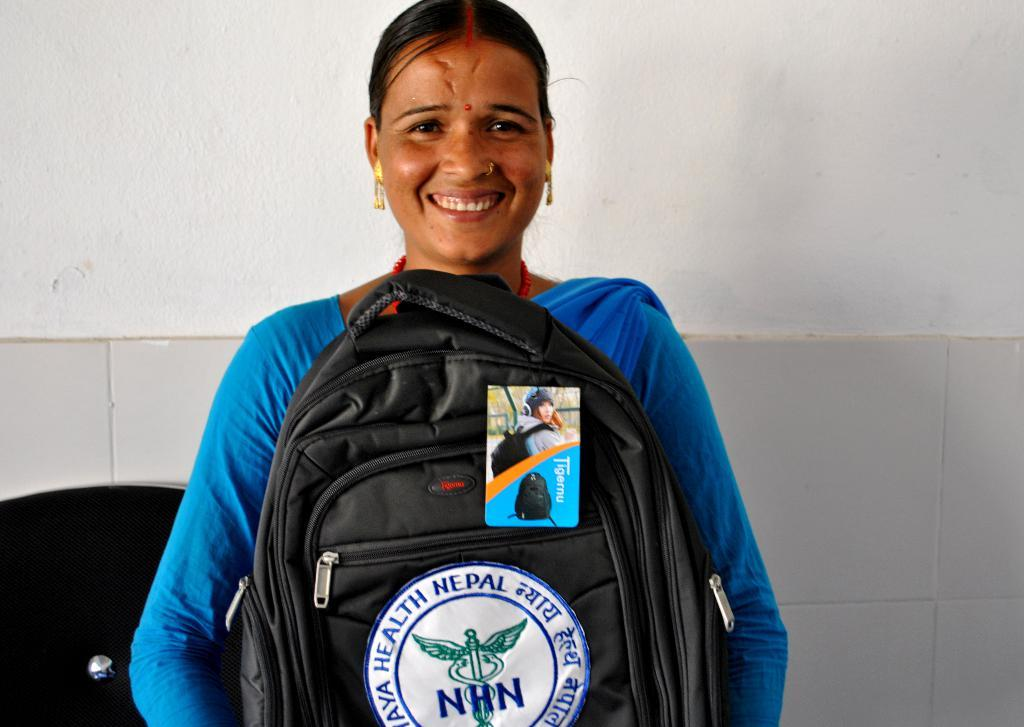Who is present in the image? There is a woman in the image. What is the woman holding in the image? The woman is holding a bag. How does the woman appear in the image? The woman has a smile on her face. What is the woman wearing in the image? The woman is wearing a blue dress. What can be seen in the background of the image? There is a wall in the background of the image. What type of paper is the woman reading in the image? There is no paper present in the image, and the woman is not reading anything. 